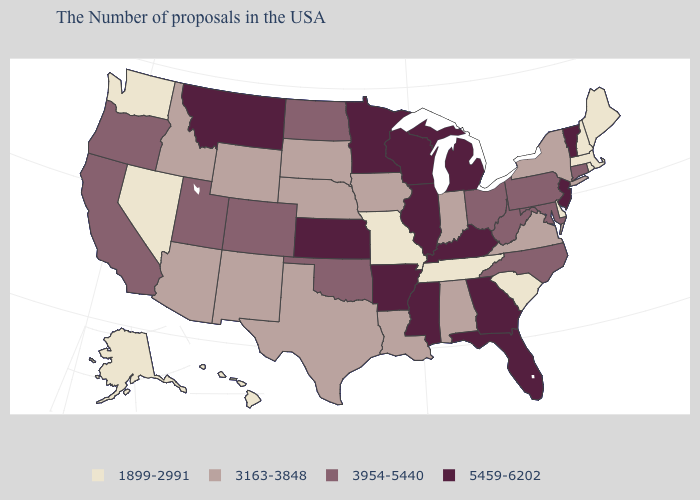Name the states that have a value in the range 1899-2991?
Give a very brief answer. Maine, Massachusetts, Rhode Island, New Hampshire, Delaware, South Carolina, Tennessee, Missouri, Nevada, Washington, Alaska, Hawaii. Does the first symbol in the legend represent the smallest category?
Short answer required. Yes. Among the states that border North Dakota , which have the lowest value?
Keep it brief. South Dakota. What is the value of Arkansas?
Answer briefly. 5459-6202. What is the value of Illinois?
Answer briefly. 5459-6202. How many symbols are there in the legend?
Quick response, please. 4. What is the value of Illinois?
Quick response, please. 5459-6202. What is the lowest value in the USA?
Write a very short answer. 1899-2991. Does the map have missing data?
Keep it brief. No. Among the states that border Utah , which have the highest value?
Keep it brief. Colorado. Among the states that border Massachusetts , does New Hampshire have the lowest value?
Short answer required. Yes. What is the value of North Dakota?
Short answer required. 3954-5440. What is the value of Idaho?
Be succinct. 3163-3848. What is the value of Hawaii?
Be succinct. 1899-2991. What is the value of Tennessee?
Answer briefly. 1899-2991. 